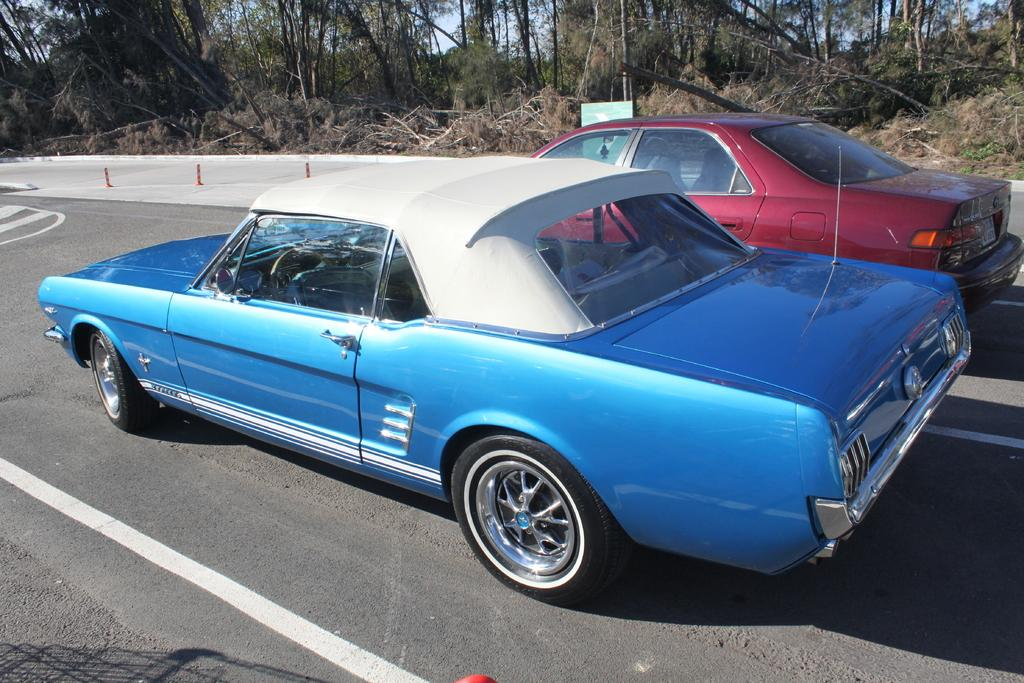How many cars can be seen on the road in the image? There are two cars on the road in the image. What else can be seen in the image besides the cars? There are poles, trees, and some unspecified objects in the image. What is visible in the background of the image? The sky is visible in the background of the image. Where is the lettuce growing in the image? There is no lettuce present in the image. What type of basin is visible in the image? There is no basin present in the image. 